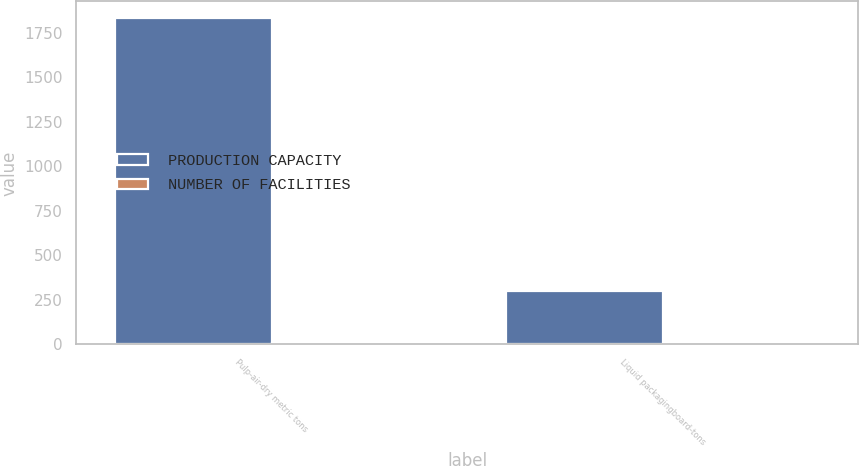<chart> <loc_0><loc_0><loc_500><loc_500><stacked_bar_chart><ecel><fcel>Pulp-air-dry metric tons<fcel>Liquid packagingboard-tons<nl><fcel>PRODUCTION CAPACITY<fcel>1835<fcel>300<nl><fcel>NUMBER OF FACILITIES<fcel>5<fcel>1<nl></chart> 